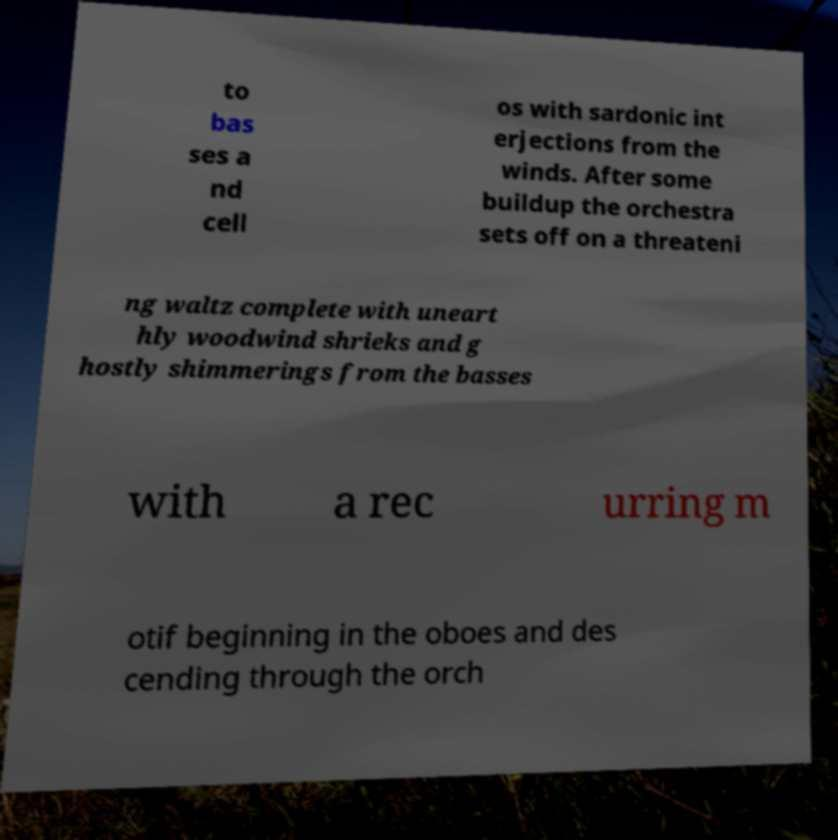Could you extract and type out the text from this image? to bas ses a nd cell os with sardonic int erjections from the winds. After some buildup the orchestra sets off on a threateni ng waltz complete with uneart hly woodwind shrieks and g hostly shimmerings from the basses with a rec urring m otif beginning in the oboes and des cending through the orch 